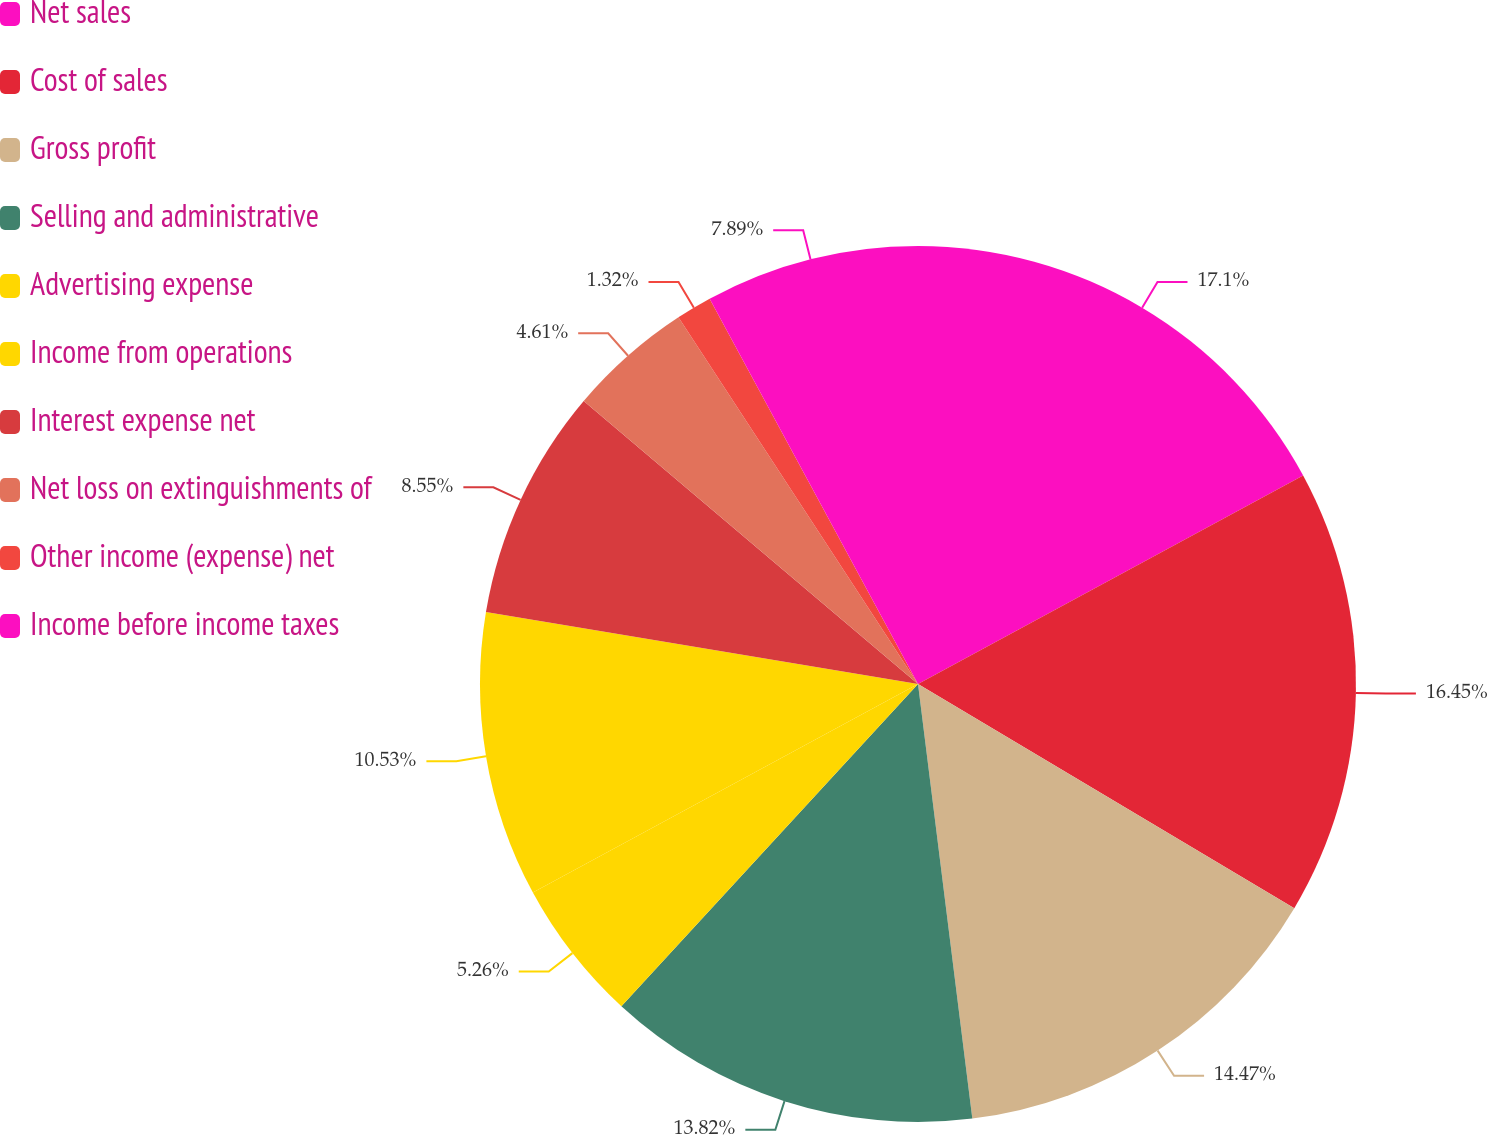<chart> <loc_0><loc_0><loc_500><loc_500><pie_chart><fcel>Net sales<fcel>Cost of sales<fcel>Gross profit<fcel>Selling and administrative<fcel>Advertising expense<fcel>Income from operations<fcel>Interest expense net<fcel>Net loss on extinguishments of<fcel>Other income (expense) net<fcel>Income before income taxes<nl><fcel>17.1%<fcel>16.45%<fcel>14.47%<fcel>13.82%<fcel>5.26%<fcel>10.53%<fcel>8.55%<fcel>4.61%<fcel>1.32%<fcel>7.89%<nl></chart> 